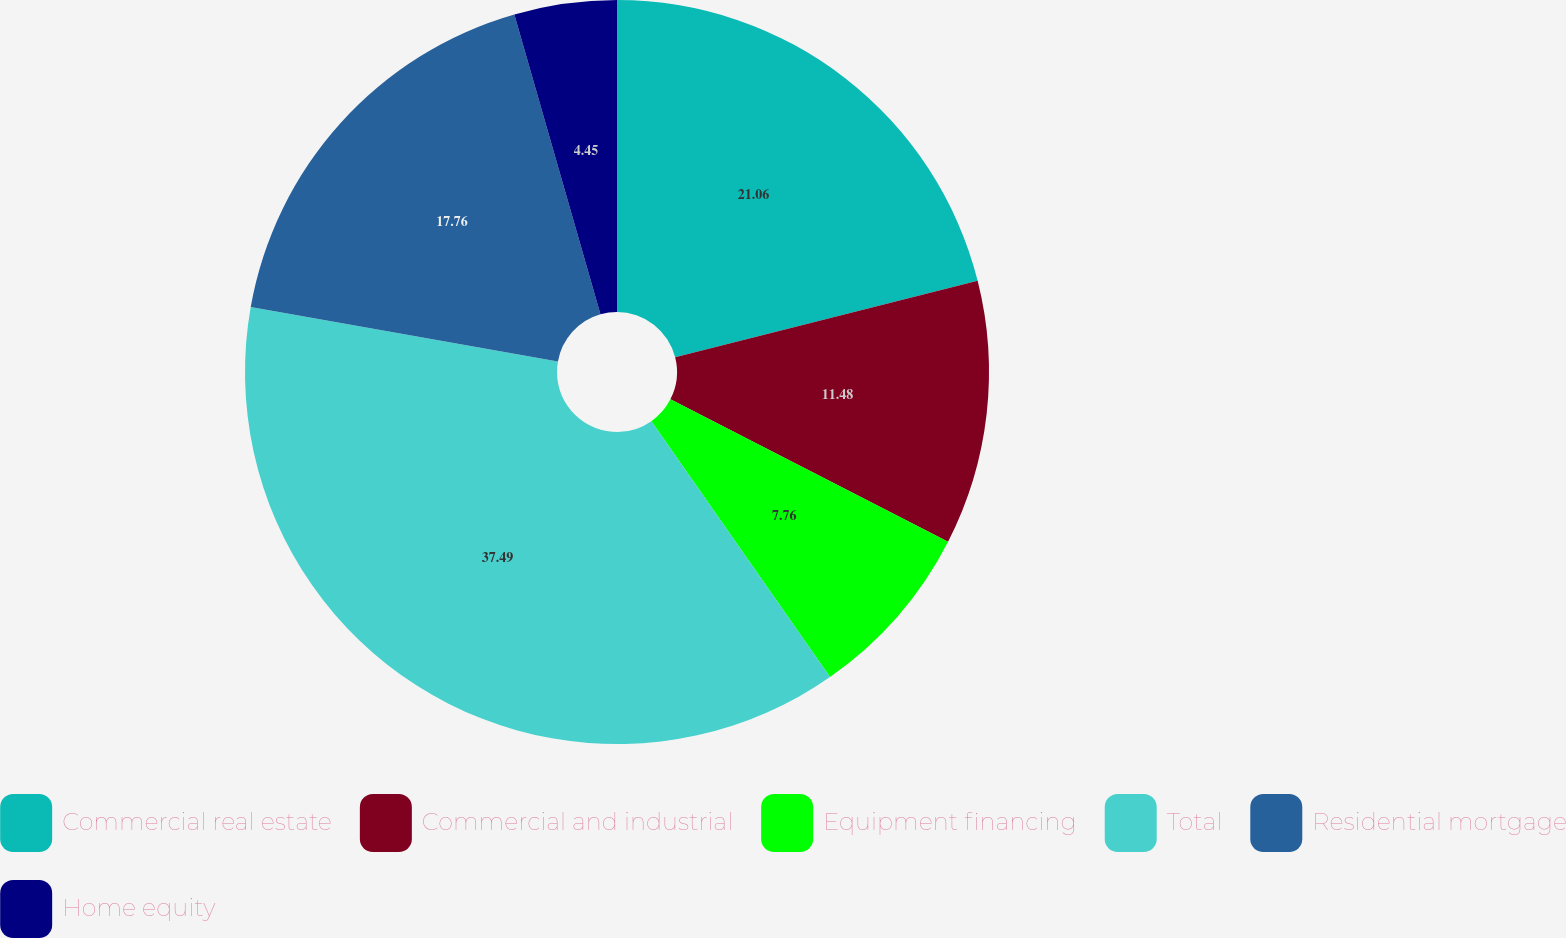<chart> <loc_0><loc_0><loc_500><loc_500><pie_chart><fcel>Commercial real estate<fcel>Commercial and industrial<fcel>Equipment financing<fcel>Total<fcel>Residential mortgage<fcel>Home equity<nl><fcel>21.06%<fcel>11.48%<fcel>7.76%<fcel>37.5%<fcel>17.76%<fcel>4.45%<nl></chart> 